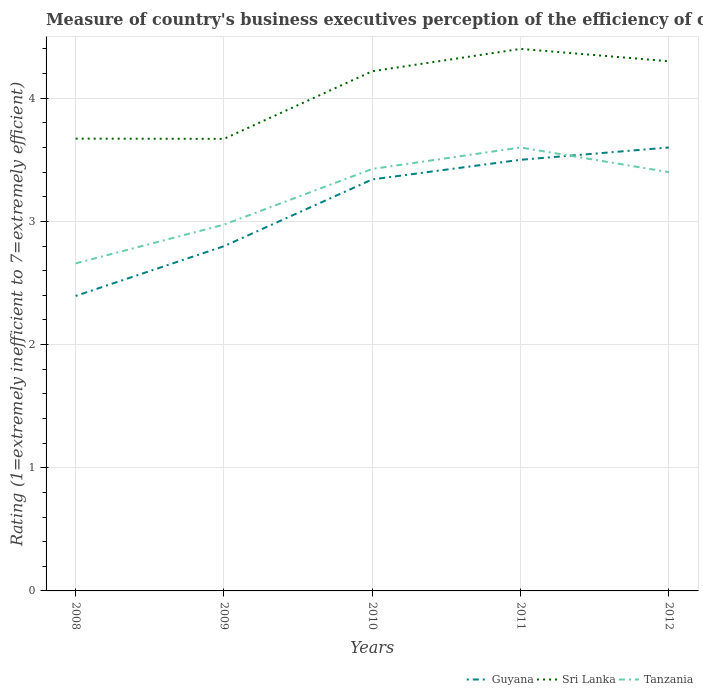How many different coloured lines are there?
Provide a succinct answer. 3. Is the number of lines equal to the number of legend labels?
Offer a terse response. Yes. Across all years, what is the maximum rating of the efficiency of customs procedure in Tanzania?
Offer a terse response. 2.66. What is the total rating of the efficiency of customs procedure in Tanzania in the graph?
Provide a short and direct response. -0.17. What is the difference between the highest and the second highest rating of the efficiency of customs procedure in Sri Lanka?
Your response must be concise. 0.73. Is the rating of the efficiency of customs procedure in Guyana strictly greater than the rating of the efficiency of customs procedure in Tanzania over the years?
Your response must be concise. No. How many lines are there?
Keep it short and to the point. 3. Are the values on the major ticks of Y-axis written in scientific E-notation?
Your answer should be compact. No. Does the graph contain any zero values?
Provide a succinct answer. No. Does the graph contain grids?
Offer a very short reply. Yes. Where does the legend appear in the graph?
Make the answer very short. Bottom right. How many legend labels are there?
Ensure brevity in your answer.  3. What is the title of the graph?
Your answer should be very brief. Measure of country's business executives perception of the efficiency of customs procedures. Does "Lao PDR" appear as one of the legend labels in the graph?
Give a very brief answer. No. What is the label or title of the X-axis?
Your answer should be very brief. Years. What is the label or title of the Y-axis?
Offer a terse response. Rating (1=extremely inefficient to 7=extremely efficient). What is the Rating (1=extremely inefficient to 7=extremely efficient) in Guyana in 2008?
Ensure brevity in your answer.  2.39. What is the Rating (1=extremely inefficient to 7=extremely efficient) of Sri Lanka in 2008?
Provide a short and direct response. 3.67. What is the Rating (1=extremely inefficient to 7=extremely efficient) of Tanzania in 2008?
Provide a succinct answer. 2.66. What is the Rating (1=extremely inefficient to 7=extremely efficient) of Guyana in 2009?
Offer a terse response. 2.8. What is the Rating (1=extremely inefficient to 7=extremely efficient) in Sri Lanka in 2009?
Offer a terse response. 3.67. What is the Rating (1=extremely inefficient to 7=extremely efficient) in Tanzania in 2009?
Offer a terse response. 2.97. What is the Rating (1=extremely inefficient to 7=extremely efficient) of Guyana in 2010?
Keep it short and to the point. 3.34. What is the Rating (1=extremely inefficient to 7=extremely efficient) of Sri Lanka in 2010?
Make the answer very short. 4.22. What is the Rating (1=extremely inefficient to 7=extremely efficient) of Tanzania in 2010?
Give a very brief answer. 3.43. What is the Rating (1=extremely inefficient to 7=extremely efficient) of Sri Lanka in 2011?
Provide a succinct answer. 4.4. What is the Rating (1=extremely inefficient to 7=extremely efficient) in Guyana in 2012?
Your response must be concise. 3.6. What is the Rating (1=extremely inefficient to 7=extremely efficient) in Tanzania in 2012?
Provide a succinct answer. 3.4. Across all years, what is the maximum Rating (1=extremely inefficient to 7=extremely efficient) of Guyana?
Keep it short and to the point. 3.6. Across all years, what is the maximum Rating (1=extremely inefficient to 7=extremely efficient) of Sri Lanka?
Your response must be concise. 4.4. Across all years, what is the maximum Rating (1=extremely inefficient to 7=extremely efficient) of Tanzania?
Offer a very short reply. 3.6. Across all years, what is the minimum Rating (1=extremely inefficient to 7=extremely efficient) in Guyana?
Ensure brevity in your answer.  2.39. Across all years, what is the minimum Rating (1=extremely inefficient to 7=extremely efficient) of Sri Lanka?
Your response must be concise. 3.67. Across all years, what is the minimum Rating (1=extremely inefficient to 7=extremely efficient) in Tanzania?
Give a very brief answer. 2.66. What is the total Rating (1=extremely inefficient to 7=extremely efficient) in Guyana in the graph?
Provide a succinct answer. 15.63. What is the total Rating (1=extremely inefficient to 7=extremely efficient) in Sri Lanka in the graph?
Offer a very short reply. 20.26. What is the total Rating (1=extremely inefficient to 7=extremely efficient) in Tanzania in the graph?
Provide a succinct answer. 16.06. What is the difference between the Rating (1=extremely inefficient to 7=extremely efficient) in Guyana in 2008 and that in 2009?
Your answer should be very brief. -0.4. What is the difference between the Rating (1=extremely inefficient to 7=extremely efficient) of Sri Lanka in 2008 and that in 2009?
Your response must be concise. 0. What is the difference between the Rating (1=extremely inefficient to 7=extremely efficient) of Tanzania in 2008 and that in 2009?
Your response must be concise. -0.31. What is the difference between the Rating (1=extremely inefficient to 7=extremely efficient) in Guyana in 2008 and that in 2010?
Your answer should be very brief. -0.95. What is the difference between the Rating (1=extremely inefficient to 7=extremely efficient) in Sri Lanka in 2008 and that in 2010?
Keep it short and to the point. -0.55. What is the difference between the Rating (1=extremely inefficient to 7=extremely efficient) in Tanzania in 2008 and that in 2010?
Keep it short and to the point. -0.77. What is the difference between the Rating (1=extremely inefficient to 7=extremely efficient) of Guyana in 2008 and that in 2011?
Give a very brief answer. -1.1. What is the difference between the Rating (1=extremely inefficient to 7=extremely efficient) of Sri Lanka in 2008 and that in 2011?
Your answer should be very brief. -0.73. What is the difference between the Rating (1=extremely inefficient to 7=extremely efficient) in Tanzania in 2008 and that in 2011?
Offer a terse response. -0.94. What is the difference between the Rating (1=extremely inefficient to 7=extremely efficient) of Guyana in 2008 and that in 2012?
Your answer should be compact. -1.21. What is the difference between the Rating (1=extremely inefficient to 7=extremely efficient) in Sri Lanka in 2008 and that in 2012?
Your answer should be compact. -0.63. What is the difference between the Rating (1=extremely inefficient to 7=extremely efficient) in Tanzania in 2008 and that in 2012?
Offer a very short reply. -0.74. What is the difference between the Rating (1=extremely inefficient to 7=extremely efficient) of Guyana in 2009 and that in 2010?
Keep it short and to the point. -0.54. What is the difference between the Rating (1=extremely inefficient to 7=extremely efficient) of Sri Lanka in 2009 and that in 2010?
Your response must be concise. -0.55. What is the difference between the Rating (1=extremely inefficient to 7=extremely efficient) of Tanzania in 2009 and that in 2010?
Ensure brevity in your answer.  -0.45. What is the difference between the Rating (1=extremely inefficient to 7=extremely efficient) of Guyana in 2009 and that in 2011?
Your answer should be very brief. -0.7. What is the difference between the Rating (1=extremely inefficient to 7=extremely efficient) in Sri Lanka in 2009 and that in 2011?
Offer a terse response. -0.73. What is the difference between the Rating (1=extremely inefficient to 7=extremely efficient) of Tanzania in 2009 and that in 2011?
Provide a succinct answer. -0.63. What is the difference between the Rating (1=extremely inefficient to 7=extremely efficient) in Guyana in 2009 and that in 2012?
Provide a short and direct response. -0.8. What is the difference between the Rating (1=extremely inefficient to 7=extremely efficient) of Sri Lanka in 2009 and that in 2012?
Give a very brief answer. -0.63. What is the difference between the Rating (1=extremely inefficient to 7=extremely efficient) of Tanzania in 2009 and that in 2012?
Make the answer very short. -0.43. What is the difference between the Rating (1=extremely inefficient to 7=extremely efficient) in Guyana in 2010 and that in 2011?
Ensure brevity in your answer.  -0.16. What is the difference between the Rating (1=extremely inefficient to 7=extremely efficient) in Sri Lanka in 2010 and that in 2011?
Provide a succinct answer. -0.18. What is the difference between the Rating (1=extremely inefficient to 7=extremely efficient) in Tanzania in 2010 and that in 2011?
Ensure brevity in your answer.  -0.17. What is the difference between the Rating (1=extremely inefficient to 7=extremely efficient) in Guyana in 2010 and that in 2012?
Your answer should be compact. -0.26. What is the difference between the Rating (1=extremely inefficient to 7=extremely efficient) of Sri Lanka in 2010 and that in 2012?
Make the answer very short. -0.08. What is the difference between the Rating (1=extremely inefficient to 7=extremely efficient) of Tanzania in 2010 and that in 2012?
Offer a terse response. 0.03. What is the difference between the Rating (1=extremely inefficient to 7=extremely efficient) in Sri Lanka in 2011 and that in 2012?
Offer a terse response. 0.1. What is the difference between the Rating (1=extremely inefficient to 7=extremely efficient) of Tanzania in 2011 and that in 2012?
Keep it short and to the point. 0.2. What is the difference between the Rating (1=extremely inefficient to 7=extremely efficient) of Guyana in 2008 and the Rating (1=extremely inefficient to 7=extremely efficient) of Sri Lanka in 2009?
Offer a very short reply. -1.27. What is the difference between the Rating (1=extremely inefficient to 7=extremely efficient) in Guyana in 2008 and the Rating (1=extremely inefficient to 7=extremely efficient) in Tanzania in 2009?
Provide a succinct answer. -0.58. What is the difference between the Rating (1=extremely inefficient to 7=extremely efficient) of Sri Lanka in 2008 and the Rating (1=extremely inefficient to 7=extremely efficient) of Tanzania in 2009?
Your answer should be compact. 0.7. What is the difference between the Rating (1=extremely inefficient to 7=extremely efficient) of Guyana in 2008 and the Rating (1=extremely inefficient to 7=extremely efficient) of Sri Lanka in 2010?
Offer a terse response. -1.82. What is the difference between the Rating (1=extremely inefficient to 7=extremely efficient) of Guyana in 2008 and the Rating (1=extremely inefficient to 7=extremely efficient) of Tanzania in 2010?
Provide a succinct answer. -1.03. What is the difference between the Rating (1=extremely inefficient to 7=extremely efficient) of Sri Lanka in 2008 and the Rating (1=extremely inefficient to 7=extremely efficient) of Tanzania in 2010?
Offer a terse response. 0.25. What is the difference between the Rating (1=extremely inefficient to 7=extremely efficient) in Guyana in 2008 and the Rating (1=extremely inefficient to 7=extremely efficient) in Sri Lanka in 2011?
Offer a terse response. -2. What is the difference between the Rating (1=extremely inefficient to 7=extremely efficient) in Guyana in 2008 and the Rating (1=extremely inefficient to 7=extremely efficient) in Tanzania in 2011?
Your answer should be compact. -1.21. What is the difference between the Rating (1=extremely inefficient to 7=extremely efficient) of Sri Lanka in 2008 and the Rating (1=extremely inefficient to 7=extremely efficient) of Tanzania in 2011?
Your answer should be compact. 0.07. What is the difference between the Rating (1=extremely inefficient to 7=extremely efficient) in Guyana in 2008 and the Rating (1=extremely inefficient to 7=extremely efficient) in Sri Lanka in 2012?
Keep it short and to the point. -1.91. What is the difference between the Rating (1=extremely inefficient to 7=extremely efficient) of Guyana in 2008 and the Rating (1=extremely inefficient to 7=extremely efficient) of Tanzania in 2012?
Provide a succinct answer. -1. What is the difference between the Rating (1=extremely inefficient to 7=extremely efficient) of Sri Lanka in 2008 and the Rating (1=extremely inefficient to 7=extremely efficient) of Tanzania in 2012?
Provide a short and direct response. 0.27. What is the difference between the Rating (1=extremely inefficient to 7=extremely efficient) in Guyana in 2009 and the Rating (1=extremely inefficient to 7=extremely efficient) in Sri Lanka in 2010?
Offer a very short reply. -1.42. What is the difference between the Rating (1=extremely inefficient to 7=extremely efficient) in Guyana in 2009 and the Rating (1=extremely inefficient to 7=extremely efficient) in Tanzania in 2010?
Keep it short and to the point. -0.63. What is the difference between the Rating (1=extremely inefficient to 7=extremely efficient) in Sri Lanka in 2009 and the Rating (1=extremely inefficient to 7=extremely efficient) in Tanzania in 2010?
Make the answer very short. 0.24. What is the difference between the Rating (1=extremely inefficient to 7=extremely efficient) in Guyana in 2009 and the Rating (1=extremely inefficient to 7=extremely efficient) in Sri Lanka in 2011?
Keep it short and to the point. -1.6. What is the difference between the Rating (1=extremely inefficient to 7=extremely efficient) of Guyana in 2009 and the Rating (1=extremely inefficient to 7=extremely efficient) of Tanzania in 2011?
Keep it short and to the point. -0.8. What is the difference between the Rating (1=extremely inefficient to 7=extremely efficient) in Sri Lanka in 2009 and the Rating (1=extremely inefficient to 7=extremely efficient) in Tanzania in 2011?
Provide a succinct answer. 0.07. What is the difference between the Rating (1=extremely inefficient to 7=extremely efficient) of Guyana in 2009 and the Rating (1=extremely inefficient to 7=extremely efficient) of Sri Lanka in 2012?
Provide a succinct answer. -1.5. What is the difference between the Rating (1=extremely inefficient to 7=extremely efficient) in Guyana in 2009 and the Rating (1=extremely inefficient to 7=extremely efficient) in Tanzania in 2012?
Your answer should be compact. -0.6. What is the difference between the Rating (1=extremely inefficient to 7=extremely efficient) of Sri Lanka in 2009 and the Rating (1=extremely inefficient to 7=extremely efficient) of Tanzania in 2012?
Provide a short and direct response. 0.27. What is the difference between the Rating (1=extremely inefficient to 7=extremely efficient) in Guyana in 2010 and the Rating (1=extremely inefficient to 7=extremely efficient) in Sri Lanka in 2011?
Keep it short and to the point. -1.06. What is the difference between the Rating (1=extremely inefficient to 7=extremely efficient) in Guyana in 2010 and the Rating (1=extremely inefficient to 7=extremely efficient) in Tanzania in 2011?
Keep it short and to the point. -0.26. What is the difference between the Rating (1=extremely inefficient to 7=extremely efficient) in Sri Lanka in 2010 and the Rating (1=extremely inefficient to 7=extremely efficient) in Tanzania in 2011?
Your answer should be very brief. 0.62. What is the difference between the Rating (1=extremely inefficient to 7=extremely efficient) in Guyana in 2010 and the Rating (1=extremely inefficient to 7=extremely efficient) in Sri Lanka in 2012?
Provide a succinct answer. -0.96. What is the difference between the Rating (1=extremely inefficient to 7=extremely efficient) of Guyana in 2010 and the Rating (1=extremely inefficient to 7=extremely efficient) of Tanzania in 2012?
Make the answer very short. -0.06. What is the difference between the Rating (1=extremely inefficient to 7=extremely efficient) of Sri Lanka in 2010 and the Rating (1=extremely inefficient to 7=extremely efficient) of Tanzania in 2012?
Give a very brief answer. 0.82. What is the difference between the Rating (1=extremely inefficient to 7=extremely efficient) in Guyana in 2011 and the Rating (1=extremely inefficient to 7=extremely efficient) in Sri Lanka in 2012?
Give a very brief answer. -0.8. What is the average Rating (1=extremely inefficient to 7=extremely efficient) in Guyana per year?
Provide a short and direct response. 3.13. What is the average Rating (1=extremely inefficient to 7=extremely efficient) of Sri Lanka per year?
Keep it short and to the point. 4.05. What is the average Rating (1=extremely inefficient to 7=extremely efficient) of Tanzania per year?
Provide a short and direct response. 3.21. In the year 2008, what is the difference between the Rating (1=extremely inefficient to 7=extremely efficient) of Guyana and Rating (1=extremely inefficient to 7=extremely efficient) of Sri Lanka?
Provide a short and direct response. -1.28. In the year 2008, what is the difference between the Rating (1=extremely inefficient to 7=extremely efficient) in Guyana and Rating (1=extremely inefficient to 7=extremely efficient) in Tanzania?
Give a very brief answer. -0.26. In the year 2008, what is the difference between the Rating (1=extremely inefficient to 7=extremely efficient) in Sri Lanka and Rating (1=extremely inefficient to 7=extremely efficient) in Tanzania?
Keep it short and to the point. 1.01. In the year 2009, what is the difference between the Rating (1=extremely inefficient to 7=extremely efficient) of Guyana and Rating (1=extremely inefficient to 7=extremely efficient) of Sri Lanka?
Make the answer very short. -0.87. In the year 2009, what is the difference between the Rating (1=extremely inefficient to 7=extremely efficient) of Guyana and Rating (1=extremely inefficient to 7=extremely efficient) of Tanzania?
Provide a succinct answer. -0.17. In the year 2009, what is the difference between the Rating (1=extremely inefficient to 7=extremely efficient) in Sri Lanka and Rating (1=extremely inefficient to 7=extremely efficient) in Tanzania?
Ensure brevity in your answer.  0.7. In the year 2010, what is the difference between the Rating (1=extremely inefficient to 7=extremely efficient) of Guyana and Rating (1=extremely inefficient to 7=extremely efficient) of Sri Lanka?
Offer a terse response. -0.88. In the year 2010, what is the difference between the Rating (1=extremely inefficient to 7=extremely efficient) of Guyana and Rating (1=extremely inefficient to 7=extremely efficient) of Tanzania?
Offer a terse response. -0.09. In the year 2010, what is the difference between the Rating (1=extremely inefficient to 7=extremely efficient) in Sri Lanka and Rating (1=extremely inefficient to 7=extremely efficient) in Tanzania?
Make the answer very short. 0.79. In the year 2011, what is the difference between the Rating (1=extremely inefficient to 7=extremely efficient) in Guyana and Rating (1=extremely inefficient to 7=extremely efficient) in Tanzania?
Provide a succinct answer. -0.1. What is the ratio of the Rating (1=extremely inefficient to 7=extremely efficient) in Guyana in 2008 to that in 2009?
Your answer should be compact. 0.86. What is the ratio of the Rating (1=extremely inefficient to 7=extremely efficient) in Sri Lanka in 2008 to that in 2009?
Provide a short and direct response. 1. What is the ratio of the Rating (1=extremely inefficient to 7=extremely efficient) of Tanzania in 2008 to that in 2009?
Offer a very short reply. 0.89. What is the ratio of the Rating (1=extremely inefficient to 7=extremely efficient) of Guyana in 2008 to that in 2010?
Your response must be concise. 0.72. What is the ratio of the Rating (1=extremely inefficient to 7=extremely efficient) of Sri Lanka in 2008 to that in 2010?
Provide a succinct answer. 0.87. What is the ratio of the Rating (1=extremely inefficient to 7=extremely efficient) in Tanzania in 2008 to that in 2010?
Offer a very short reply. 0.78. What is the ratio of the Rating (1=extremely inefficient to 7=extremely efficient) of Guyana in 2008 to that in 2011?
Make the answer very short. 0.68. What is the ratio of the Rating (1=extremely inefficient to 7=extremely efficient) in Sri Lanka in 2008 to that in 2011?
Your answer should be compact. 0.83. What is the ratio of the Rating (1=extremely inefficient to 7=extremely efficient) of Tanzania in 2008 to that in 2011?
Provide a succinct answer. 0.74. What is the ratio of the Rating (1=extremely inefficient to 7=extremely efficient) in Guyana in 2008 to that in 2012?
Give a very brief answer. 0.67. What is the ratio of the Rating (1=extremely inefficient to 7=extremely efficient) in Sri Lanka in 2008 to that in 2012?
Offer a very short reply. 0.85. What is the ratio of the Rating (1=extremely inefficient to 7=extremely efficient) of Tanzania in 2008 to that in 2012?
Your answer should be compact. 0.78. What is the ratio of the Rating (1=extremely inefficient to 7=extremely efficient) in Guyana in 2009 to that in 2010?
Provide a short and direct response. 0.84. What is the ratio of the Rating (1=extremely inefficient to 7=extremely efficient) in Sri Lanka in 2009 to that in 2010?
Ensure brevity in your answer.  0.87. What is the ratio of the Rating (1=extremely inefficient to 7=extremely efficient) in Tanzania in 2009 to that in 2010?
Keep it short and to the point. 0.87. What is the ratio of the Rating (1=extremely inefficient to 7=extremely efficient) in Guyana in 2009 to that in 2011?
Offer a terse response. 0.8. What is the ratio of the Rating (1=extremely inefficient to 7=extremely efficient) in Sri Lanka in 2009 to that in 2011?
Give a very brief answer. 0.83. What is the ratio of the Rating (1=extremely inefficient to 7=extremely efficient) in Tanzania in 2009 to that in 2011?
Ensure brevity in your answer.  0.83. What is the ratio of the Rating (1=extremely inefficient to 7=extremely efficient) in Guyana in 2009 to that in 2012?
Ensure brevity in your answer.  0.78. What is the ratio of the Rating (1=extremely inefficient to 7=extremely efficient) of Sri Lanka in 2009 to that in 2012?
Offer a very short reply. 0.85. What is the ratio of the Rating (1=extremely inefficient to 7=extremely efficient) of Tanzania in 2009 to that in 2012?
Keep it short and to the point. 0.87. What is the ratio of the Rating (1=extremely inefficient to 7=extremely efficient) of Guyana in 2010 to that in 2011?
Keep it short and to the point. 0.95. What is the ratio of the Rating (1=extremely inefficient to 7=extremely efficient) in Sri Lanka in 2010 to that in 2011?
Keep it short and to the point. 0.96. What is the ratio of the Rating (1=extremely inefficient to 7=extremely efficient) in Tanzania in 2010 to that in 2011?
Offer a terse response. 0.95. What is the ratio of the Rating (1=extremely inefficient to 7=extremely efficient) of Guyana in 2010 to that in 2012?
Your answer should be compact. 0.93. What is the ratio of the Rating (1=extremely inefficient to 7=extremely efficient) of Sri Lanka in 2010 to that in 2012?
Ensure brevity in your answer.  0.98. What is the ratio of the Rating (1=extremely inefficient to 7=extremely efficient) of Tanzania in 2010 to that in 2012?
Give a very brief answer. 1.01. What is the ratio of the Rating (1=extremely inefficient to 7=extremely efficient) in Guyana in 2011 to that in 2012?
Offer a terse response. 0.97. What is the ratio of the Rating (1=extremely inefficient to 7=extremely efficient) in Sri Lanka in 2011 to that in 2012?
Offer a very short reply. 1.02. What is the ratio of the Rating (1=extremely inefficient to 7=extremely efficient) in Tanzania in 2011 to that in 2012?
Keep it short and to the point. 1.06. What is the difference between the highest and the second highest Rating (1=extremely inefficient to 7=extremely efficient) of Guyana?
Offer a terse response. 0.1. What is the difference between the highest and the second highest Rating (1=extremely inefficient to 7=extremely efficient) of Sri Lanka?
Provide a short and direct response. 0.1. What is the difference between the highest and the second highest Rating (1=extremely inefficient to 7=extremely efficient) in Tanzania?
Provide a succinct answer. 0.17. What is the difference between the highest and the lowest Rating (1=extremely inefficient to 7=extremely efficient) of Guyana?
Offer a terse response. 1.21. What is the difference between the highest and the lowest Rating (1=extremely inefficient to 7=extremely efficient) in Sri Lanka?
Provide a succinct answer. 0.73. What is the difference between the highest and the lowest Rating (1=extremely inefficient to 7=extremely efficient) in Tanzania?
Your answer should be very brief. 0.94. 